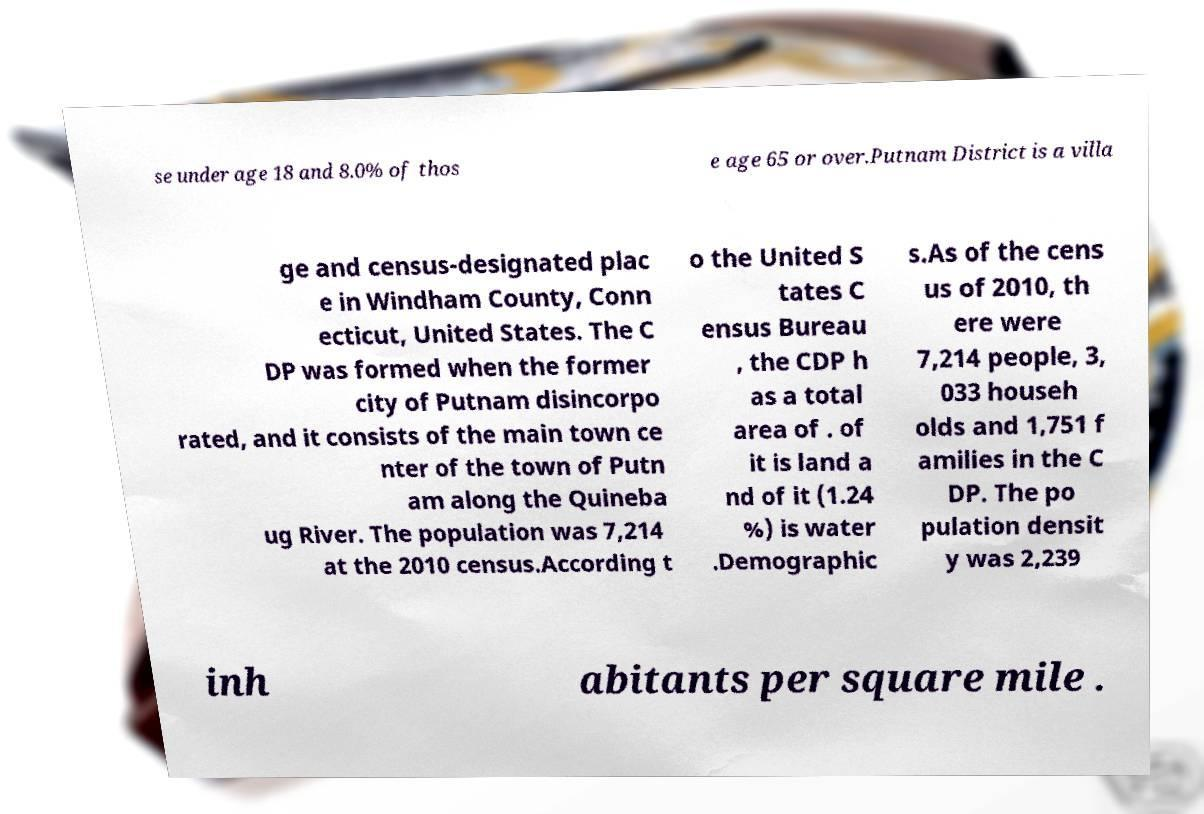What messages or text are displayed in this image? I need them in a readable, typed format. se under age 18 and 8.0% of thos e age 65 or over.Putnam District is a villa ge and census-designated plac e in Windham County, Conn ecticut, United States. The C DP was formed when the former city of Putnam disincorpo rated, and it consists of the main town ce nter of the town of Putn am along the Quineba ug River. The population was 7,214 at the 2010 census.According t o the United S tates C ensus Bureau , the CDP h as a total area of . of it is land a nd of it (1.24 %) is water .Demographic s.As of the cens us of 2010, th ere were 7,214 people, 3, 033 househ olds and 1,751 f amilies in the C DP. The po pulation densit y was 2,239 inh abitants per square mile . 